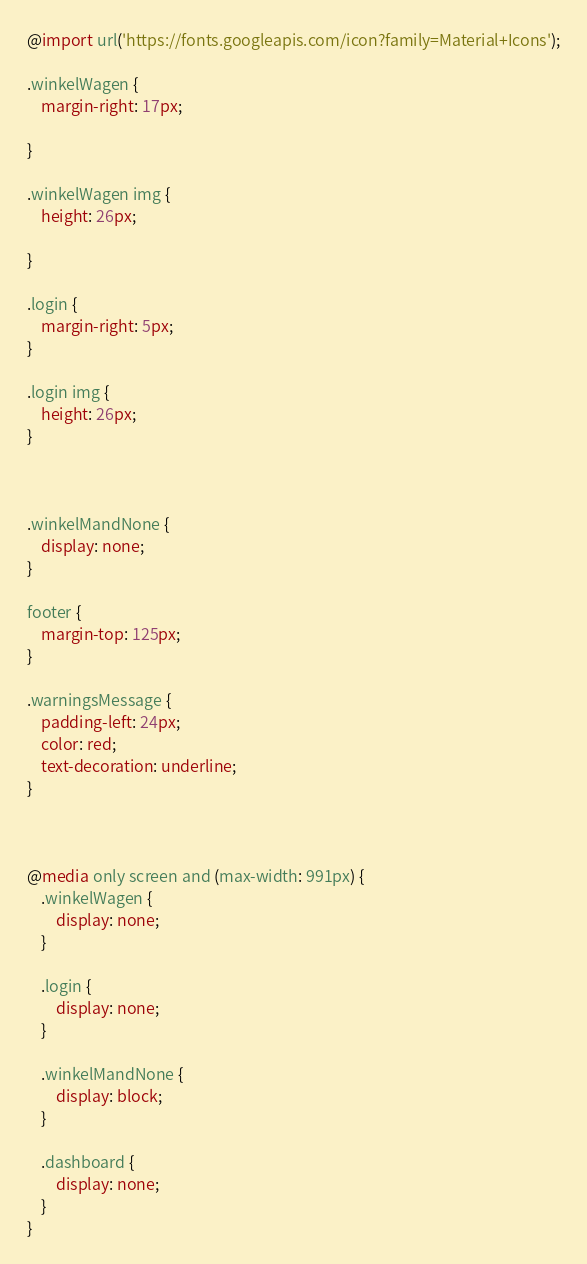Convert code to text. <code><loc_0><loc_0><loc_500><loc_500><_CSS_>@import url('https://fonts.googleapis.com/icon?family=Material+Icons');

.winkelWagen {
    margin-right: 17px;

}

.winkelWagen img {
    height: 26px;

}

.login {
    margin-right: 5px;
}

.login img {
    height: 26px;
}



.winkelMandNone {
    display: none;
}

footer {
    margin-top: 125px;
}

.warningsMessage {
    padding-left: 24px;
    color: red;
    text-decoration: underline;
}



@media only screen and (max-width: 991px) {
    .winkelWagen {
        display: none;
    }

    .login {
        display: none;
    }

    .winkelMandNone {
        display: block;
    }

    .dashboard {
        display: none;
    }
}

</code> 